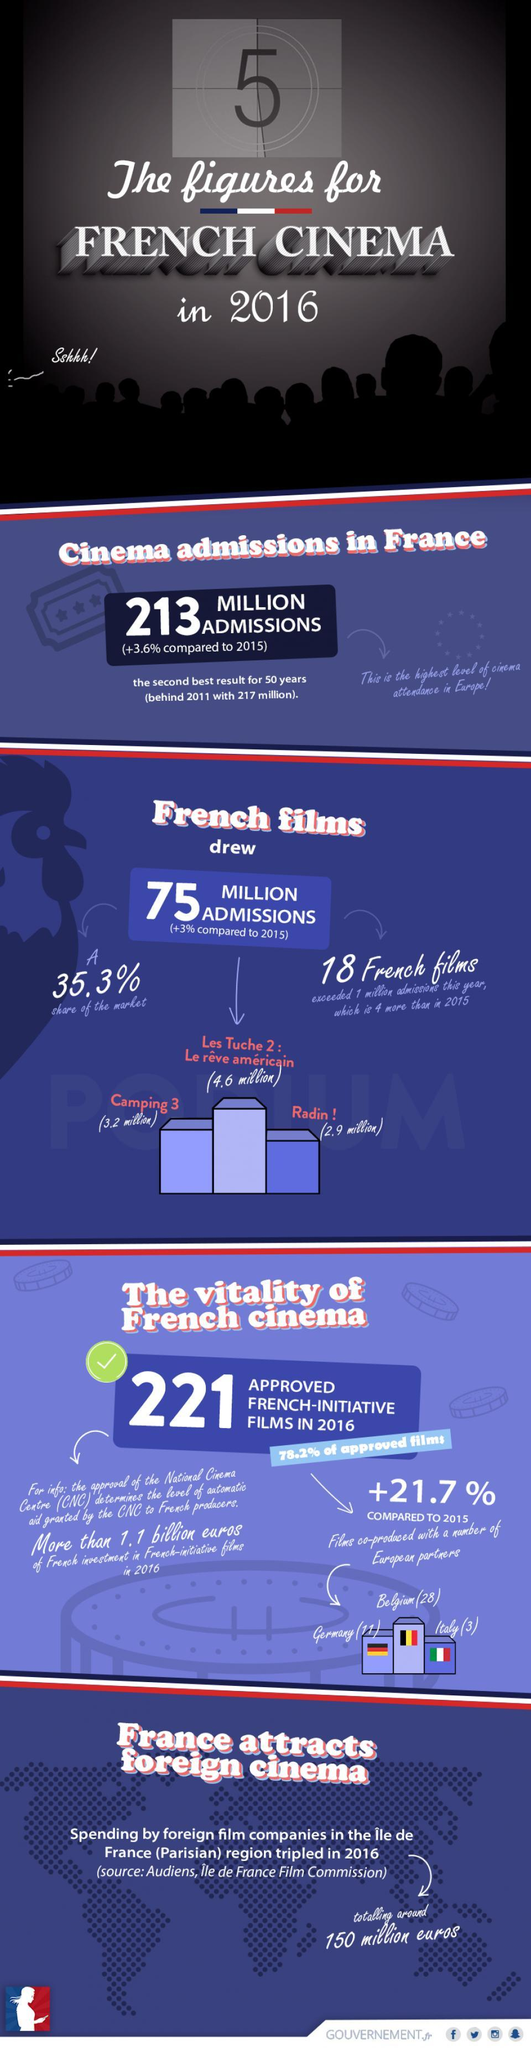By how much was the admissions to the movie "Camping 3" higher than "Radin ! "(in millions)?
Answer the question with a short phrase. 0.3 What was the best result for cinema admissions in France? 217 million What was the number of admissions, for the French movie  "Camping 3" ? 3.2 million What is the highest level of cinema attendance in Europe? 213 million How many French films, exceeded 1 million admissions last year (2015)? 14 In the image of the movie theatre, what is one of the viewers saying? Sshhh! Which are the European partners, with which the French have co-produced films? Belgium, Germany, Italy From the total 213 million cinema admissions in France, how many were for non-French films? 138 